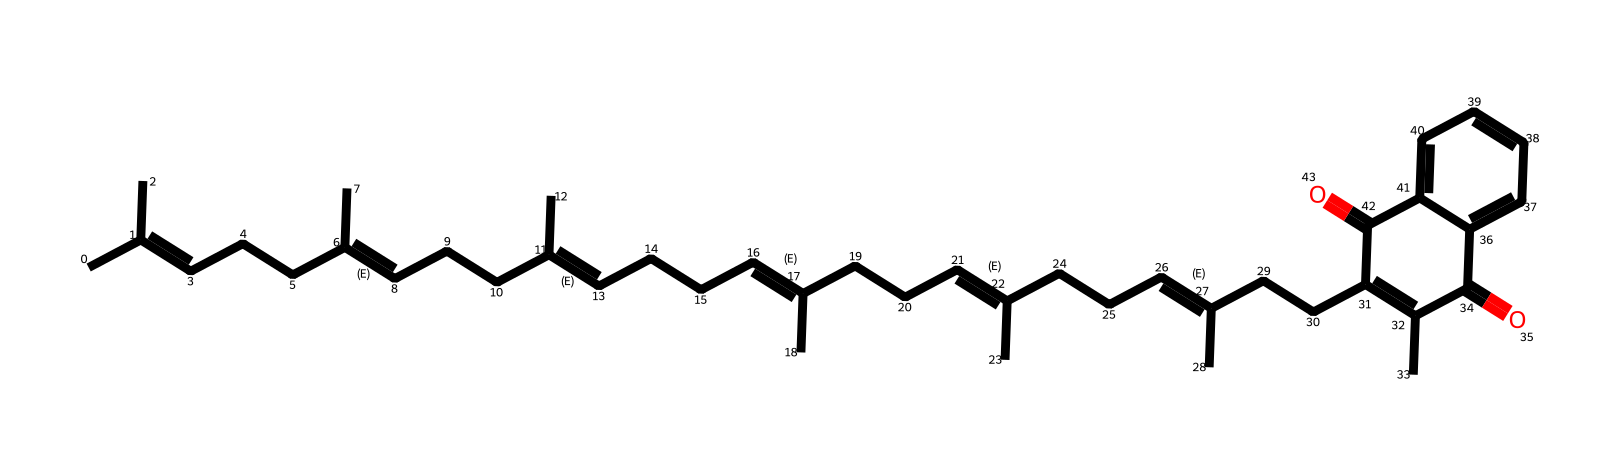What is the number of carbon atoms in vitamin K2? By counting the "C" symbols in the SMILES representation, including branches, it can be determined that there are 30 carbon atoms present.
Answer: 30 How many double bonds are present in this structure? The double bonds are indicated by the "C=C" in the SMILES representation. By reviewing the structure, we can identify six double bond positions, which correspond to the six C=C bonds.
Answer: 6 What is the type of functional group featured prominently in vitamin K2? The presence of "C=O" indicates carbonyl groups in the structure. Since there are two instances of carbonyls, it confirms the ketone functional group is featured.
Answer: ketone What is the molecular geometry around the double-bonded carbons? The geometry around double-bonded carbons is typically planar due to the sp2 hybridization of these carbon atoms.
Answer: planar How many rings are present in the molecular structure of vitamin K2? There is one distinct ring structure identified based on the connectivity in the SMILES. It is characterized by the cyclic portion at the end of the SMILES.
Answer: 1 What is the primary structural feature that distinguishes vitamin K2 from other vitamins? The extended conjugated double bond system is the primary feature of vitamin K2, which influences its functionality and biological roles.
Answer: extended conjugation 